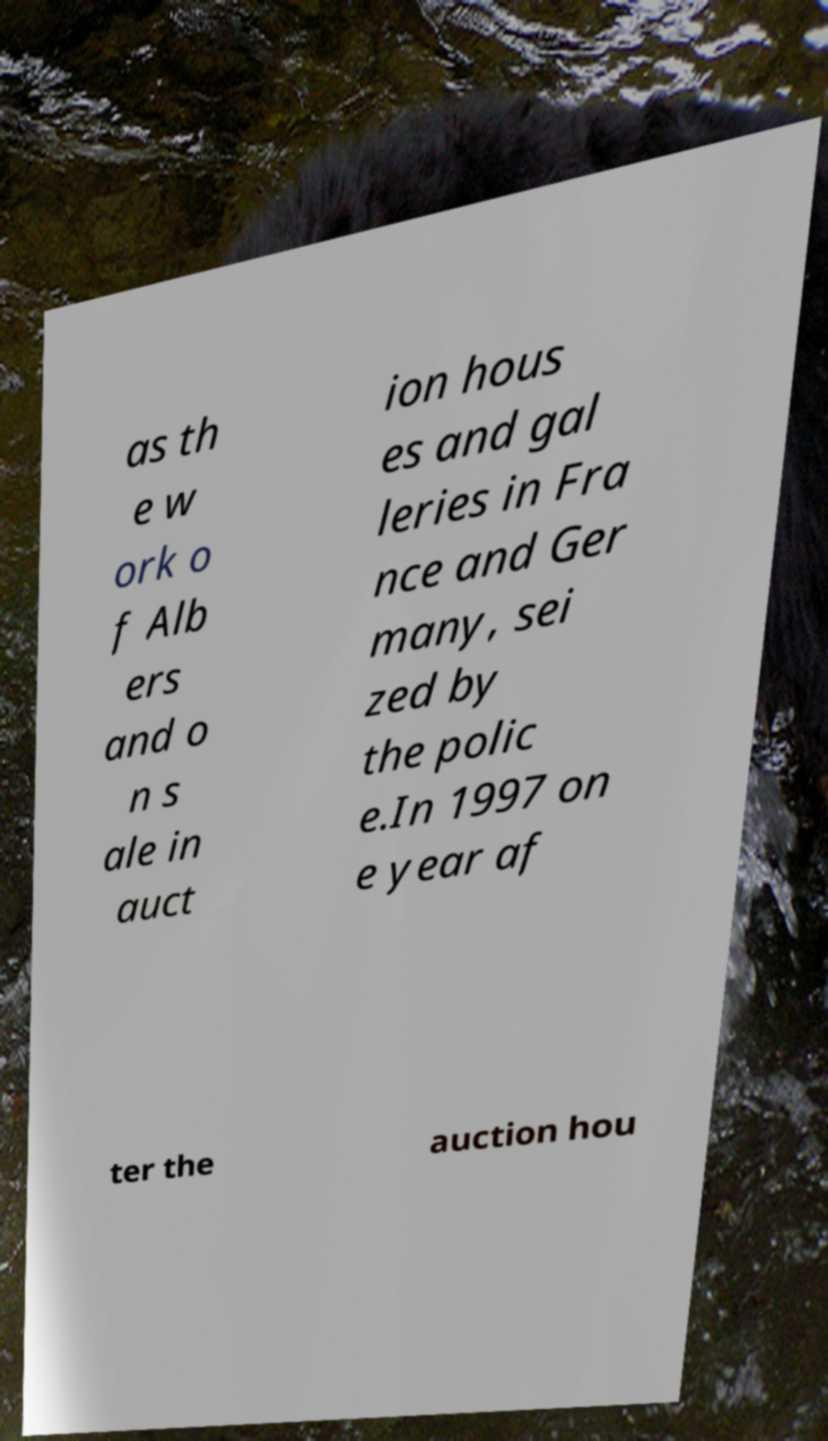Can you read and provide the text displayed in the image?This photo seems to have some interesting text. Can you extract and type it out for me? as th e w ork o f Alb ers and o n s ale in auct ion hous es and gal leries in Fra nce and Ger many, sei zed by the polic e.In 1997 on e year af ter the auction hou 